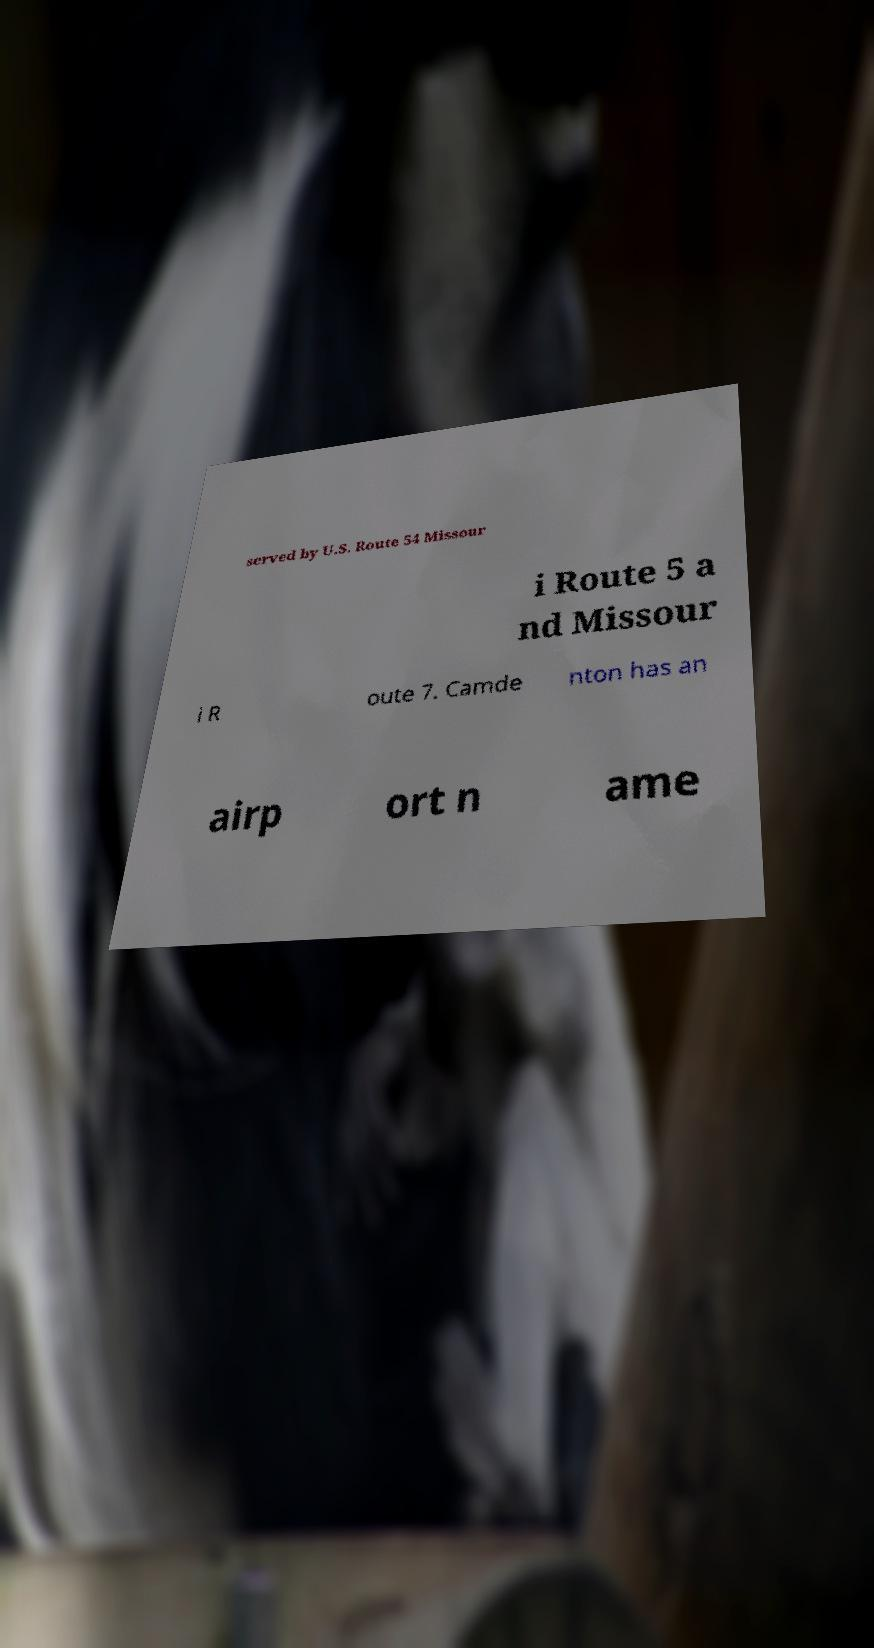Please read and relay the text visible in this image. What does it say? served by U.S. Route 54 Missour i Route 5 a nd Missour i R oute 7. Camde nton has an airp ort n ame 